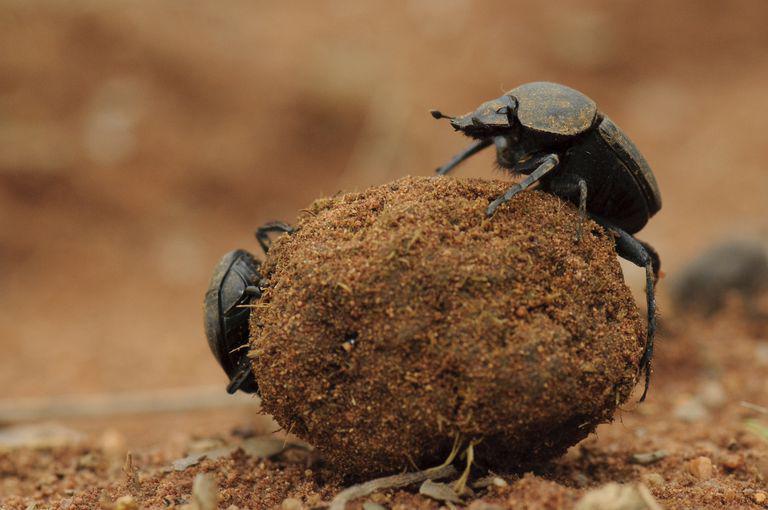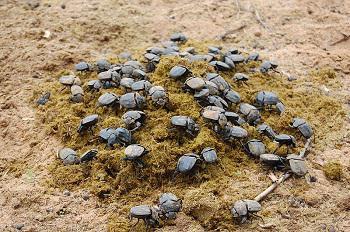The first image is the image on the left, the second image is the image on the right. For the images shown, is this caption "The image on the left shows two beetles on top of a dungball." true? Answer yes or no. Yes. 